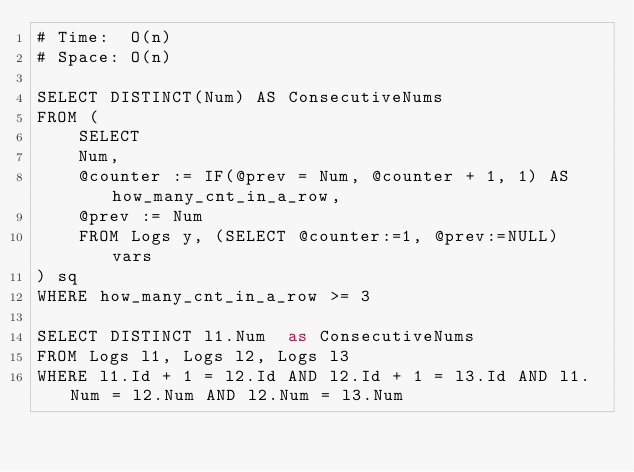Convert code to text. <code><loc_0><loc_0><loc_500><loc_500><_SQL_># Time:  O(n)
# Space: O(n)

SELECT DISTINCT(Num) AS ConsecutiveNums
FROM (
    SELECT
    Num,
    @counter := IF(@prev = Num, @counter + 1, 1) AS how_many_cnt_in_a_row,
    @prev := Num
    FROM Logs y, (SELECT @counter:=1, @prev:=NULL) vars
) sq
WHERE how_many_cnt_in_a_row >= 3

SELECT DISTINCT l1.Num  as ConsecutiveNums
FROM Logs l1, Logs l2, Logs l3  
WHERE l1.Id + 1 = l2.Id AND l2.Id + 1 = l3.Id AND l1.Num = l2.Num AND l2.Num = l3.Num 

</code> 